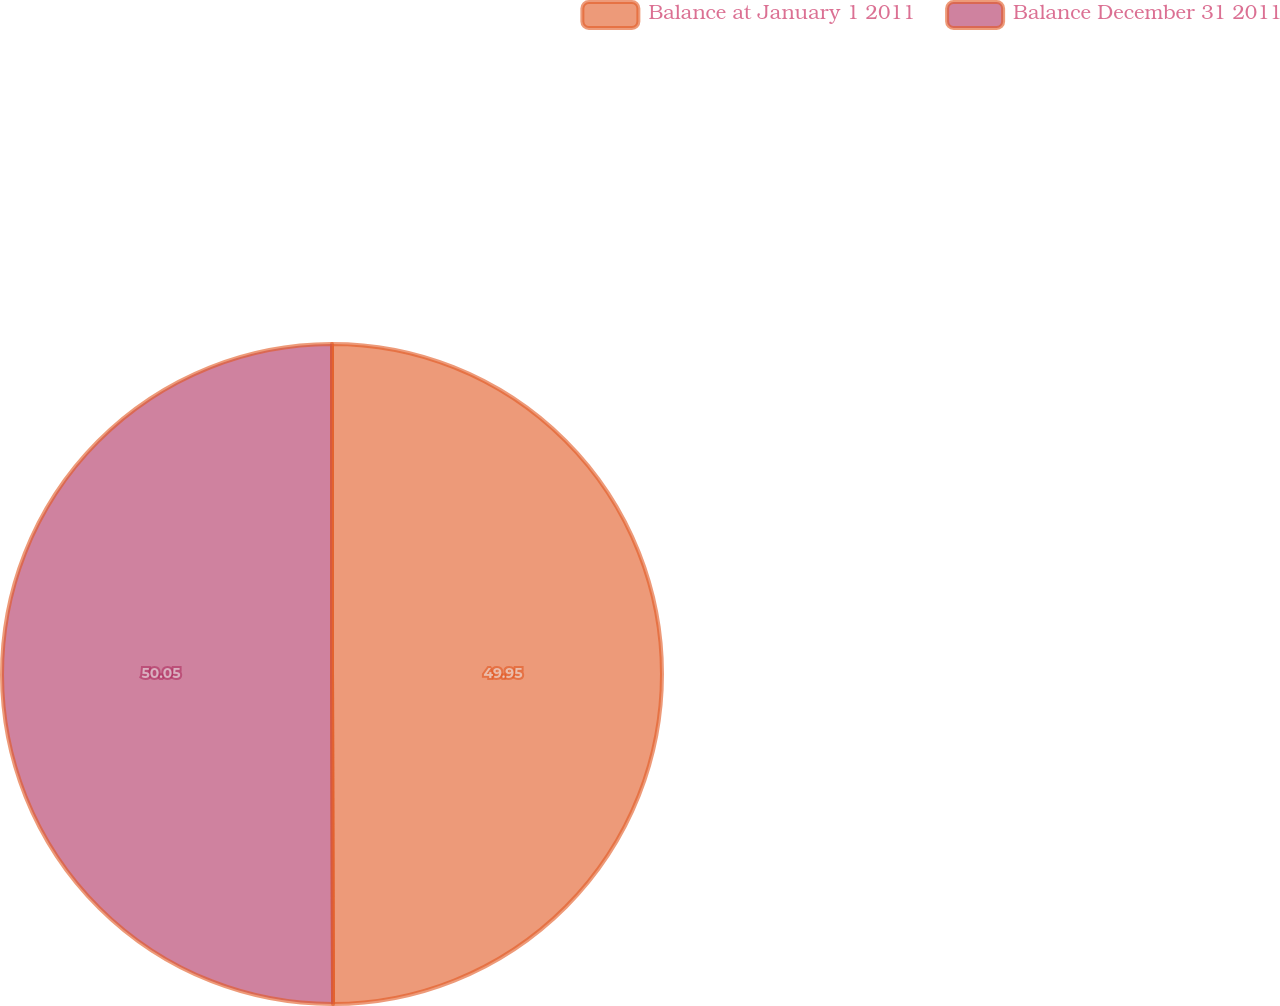<chart> <loc_0><loc_0><loc_500><loc_500><pie_chart><fcel>Balance at January 1 2011<fcel>Balance December 31 2011<nl><fcel>49.95%<fcel>50.05%<nl></chart> 